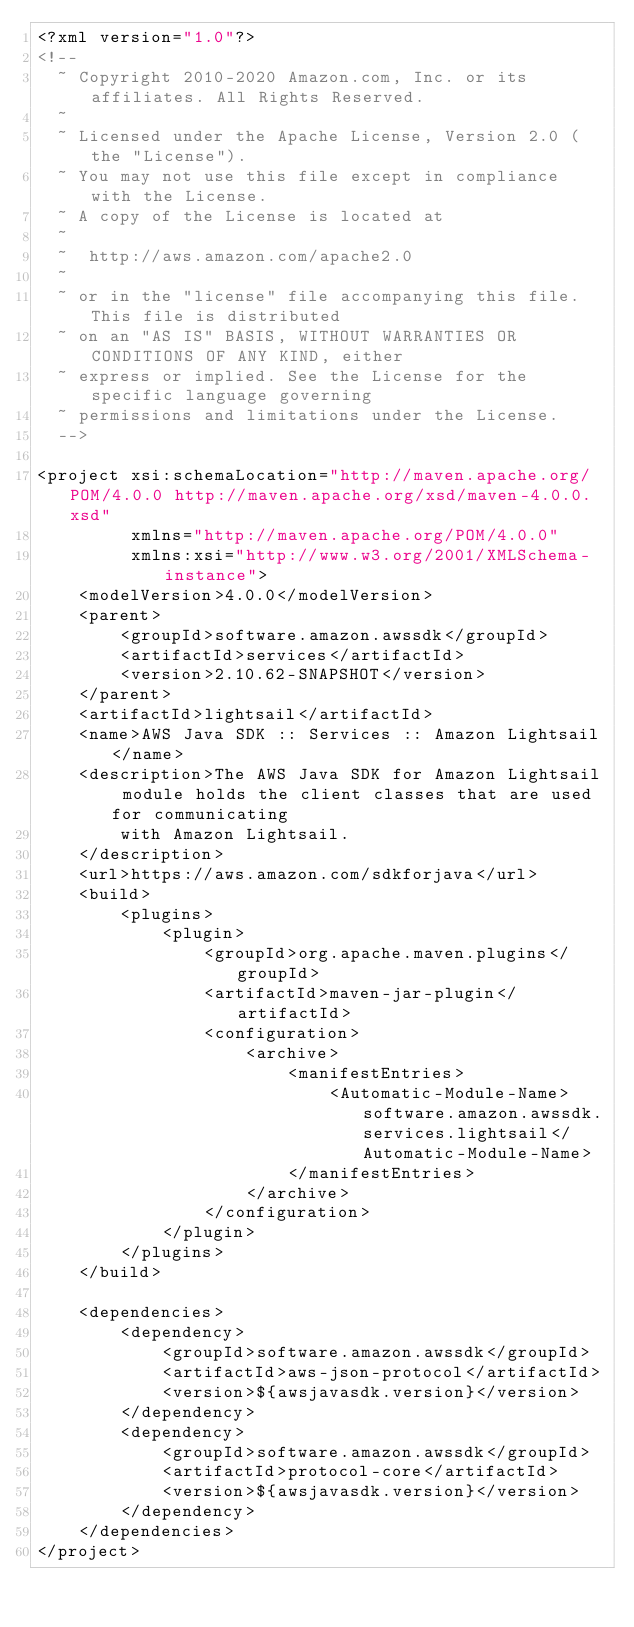Convert code to text. <code><loc_0><loc_0><loc_500><loc_500><_XML_><?xml version="1.0"?>
<!--
  ~ Copyright 2010-2020 Amazon.com, Inc. or its affiliates. All Rights Reserved.
  ~
  ~ Licensed under the Apache License, Version 2.0 (the "License").
  ~ You may not use this file except in compliance with the License.
  ~ A copy of the License is located at
  ~
  ~  http://aws.amazon.com/apache2.0
  ~
  ~ or in the "license" file accompanying this file. This file is distributed
  ~ on an "AS IS" BASIS, WITHOUT WARRANTIES OR CONDITIONS OF ANY KIND, either
  ~ express or implied. See the License for the specific language governing
  ~ permissions and limitations under the License.
  -->

<project xsi:schemaLocation="http://maven.apache.org/POM/4.0.0 http://maven.apache.org/xsd/maven-4.0.0.xsd"
         xmlns="http://maven.apache.org/POM/4.0.0"
         xmlns:xsi="http://www.w3.org/2001/XMLSchema-instance">
    <modelVersion>4.0.0</modelVersion>
    <parent>
        <groupId>software.amazon.awssdk</groupId>
        <artifactId>services</artifactId>
        <version>2.10.62-SNAPSHOT</version>
    </parent>
    <artifactId>lightsail</artifactId>
    <name>AWS Java SDK :: Services :: Amazon Lightsail</name>
    <description>The AWS Java SDK for Amazon Lightsail module holds the client classes that are used for communicating
        with Amazon Lightsail.
    </description>
    <url>https://aws.amazon.com/sdkforjava</url>
    <build>
        <plugins>
            <plugin>
                <groupId>org.apache.maven.plugins</groupId>
                <artifactId>maven-jar-plugin</artifactId>
                <configuration>
                    <archive>
                        <manifestEntries>
                            <Automatic-Module-Name>software.amazon.awssdk.services.lightsail</Automatic-Module-Name>
                        </manifestEntries>
                    </archive>
                </configuration>
            </plugin>
        </plugins>
    </build>

    <dependencies>
        <dependency>
            <groupId>software.amazon.awssdk</groupId>
            <artifactId>aws-json-protocol</artifactId>
            <version>${awsjavasdk.version}</version>
        </dependency>
        <dependency>
            <groupId>software.amazon.awssdk</groupId>
            <artifactId>protocol-core</artifactId>
            <version>${awsjavasdk.version}</version>
        </dependency>
    </dependencies>
</project>
</code> 